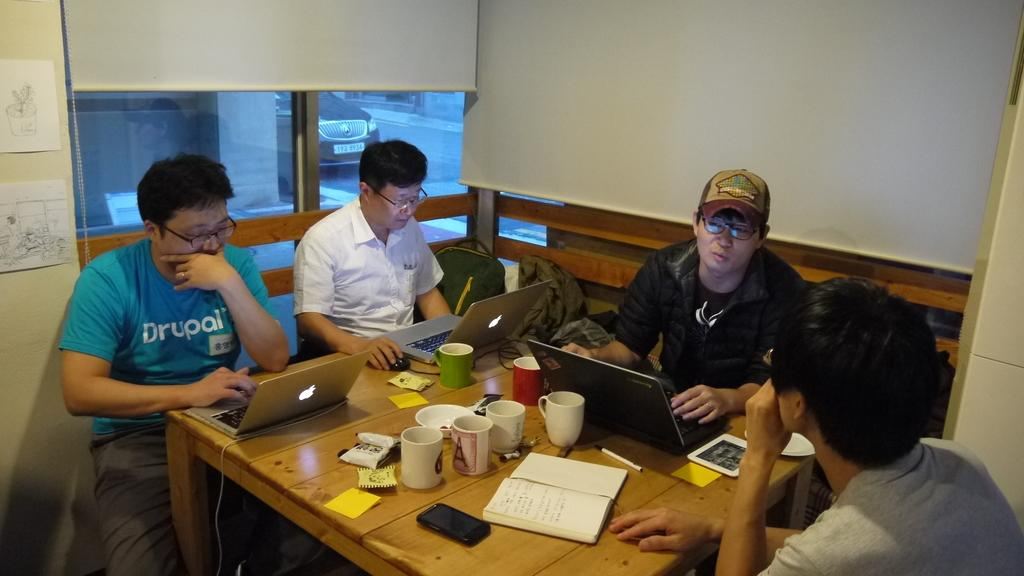How many people are present in the image? There are four people in the image. What are the people doing in the image? The people are sitting on chairs. How are the chairs arranged in the image? The chairs are arranged around a table. What objects can be seen on the table in the image? There are laptops, books, and cups on the table. What type of lettuce is being used as a twig in the image? There is no lettuce or twig present in the image. 